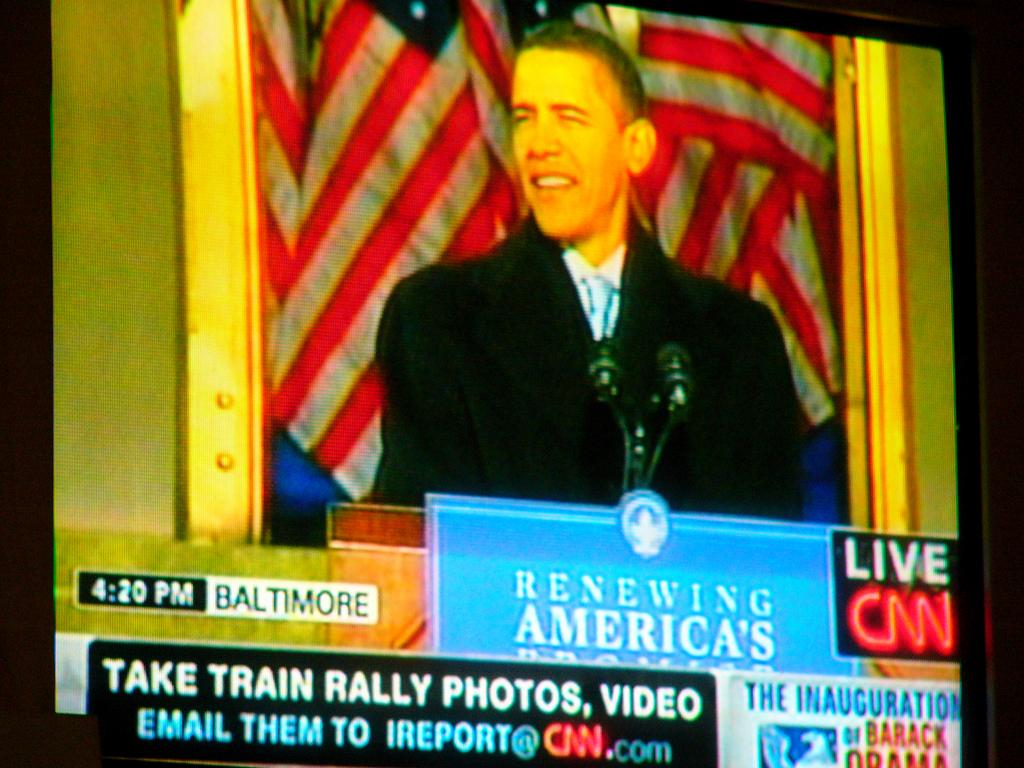<image>
Present a compact description of the photo's key features. A TV screen shows Barack Obama making a speech and displays the Baltimore time of 4:20 PM. 